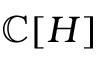Convert formula to latex. <formula><loc_0><loc_0><loc_500><loc_500>\mathbb { C } [ H ]</formula> 